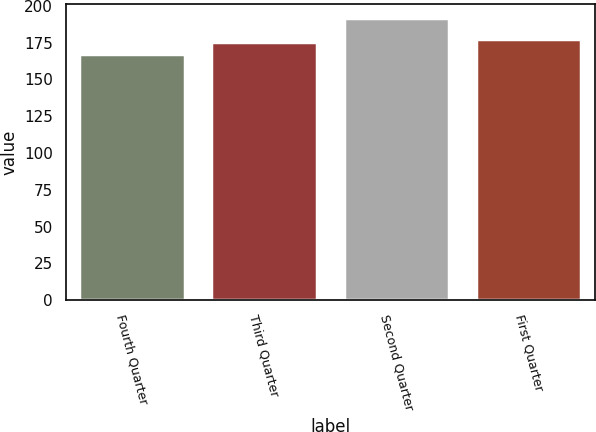Convert chart to OTSL. <chart><loc_0><loc_0><loc_500><loc_500><bar_chart><fcel>Fourth Quarter<fcel>Third Quarter<fcel>Second Quarter<fcel>First Quarter<nl><fcel>167.13<fcel>175.28<fcel>191.95<fcel>177.76<nl></chart> 